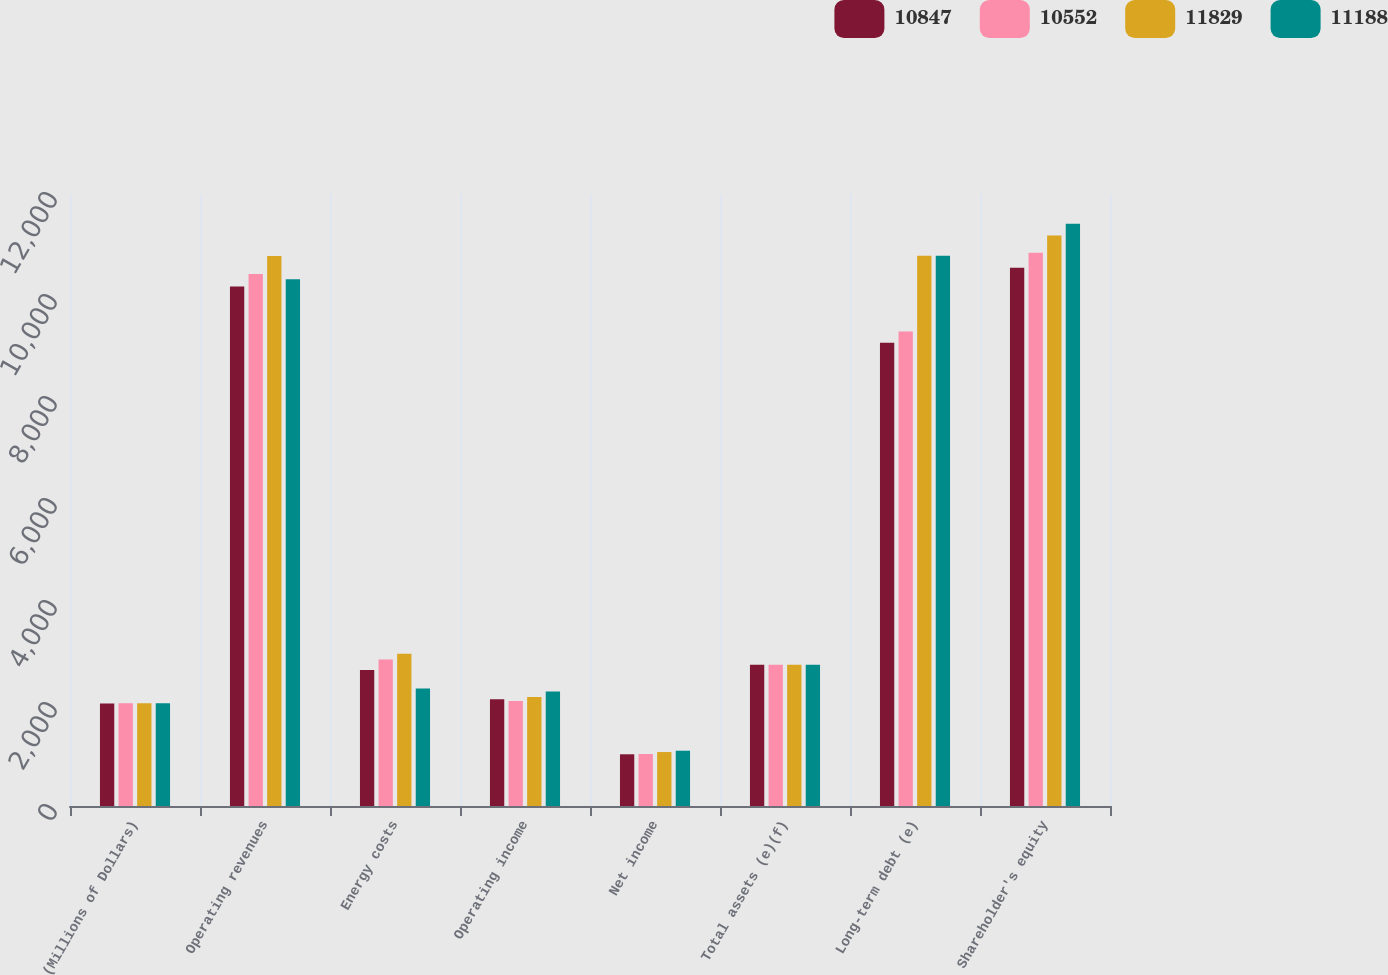Convert chart to OTSL. <chart><loc_0><loc_0><loc_500><loc_500><stacked_bar_chart><ecel><fcel>(Millions of Dollars)<fcel>Operating revenues<fcel>Energy costs<fcel>Operating income<fcel>Net income<fcel>Total assets (e)(f)<fcel>Long-term debt (e)<fcel>Shareholder's equity<nl><fcel>10847<fcel>2012<fcel>10187<fcel>2665<fcel>2093<fcel>1014<fcel>2769<fcel>9083<fcel>10552<nl><fcel>10552<fcel>2013<fcel>10430<fcel>2873<fcel>2060<fcel>1020<fcel>2769<fcel>9303<fcel>10847<nl><fcel>11829<fcel>2014<fcel>10786<fcel>2985<fcel>2139<fcel>1058<fcel>2769<fcel>10788<fcel>11188<nl><fcel>11188<fcel>2015<fcel>10328<fcel>2304<fcel>2247<fcel>1084<fcel>2769<fcel>10787<fcel>11415<nl></chart> 